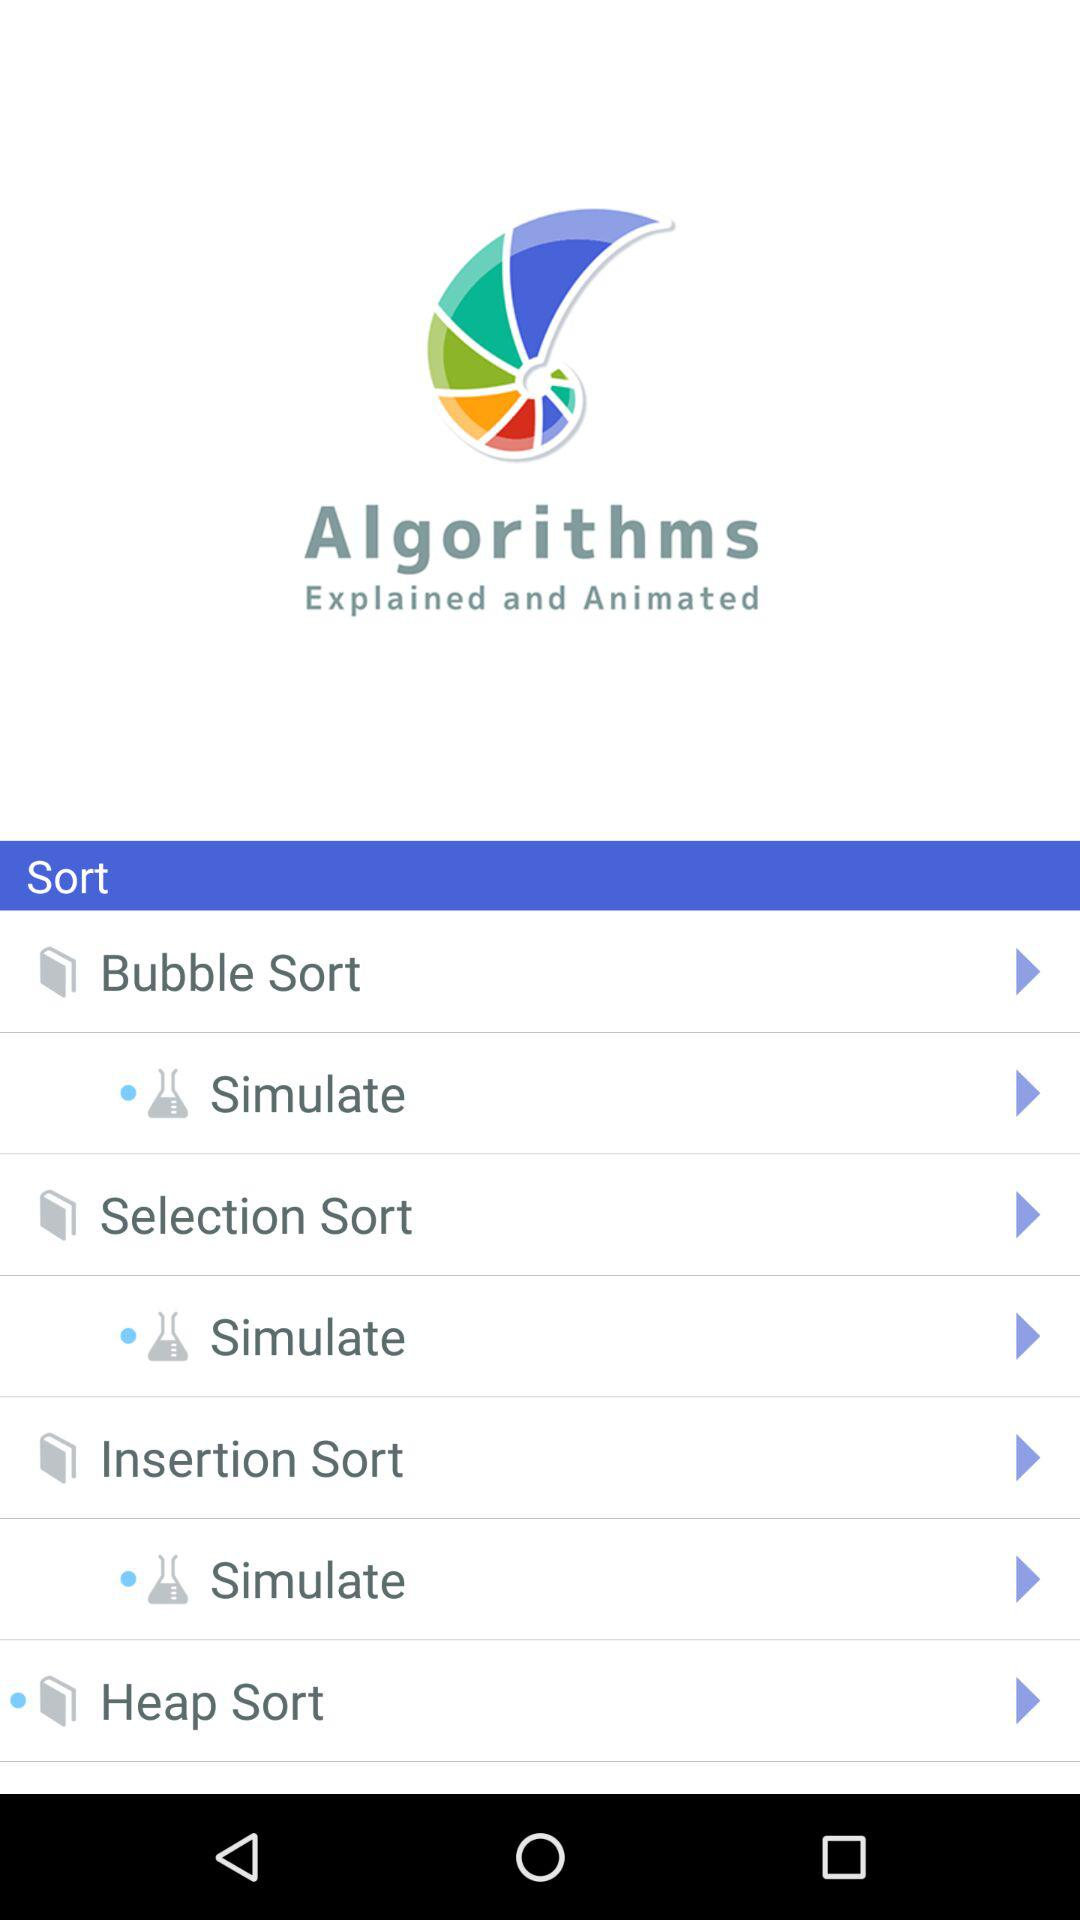What is the app name? The app name is "Algorithms". 